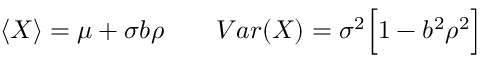Convert formula to latex. <formula><loc_0><loc_0><loc_500><loc_500>\begin{array} { r } { \langle X \rangle = \mu + \sigma b \rho \quad V a r ( X ) = \sigma ^ { 2 } \left [ 1 - b ^ { 2 } \rho ^ { 2 } \right ] } \end{array}</formula> 